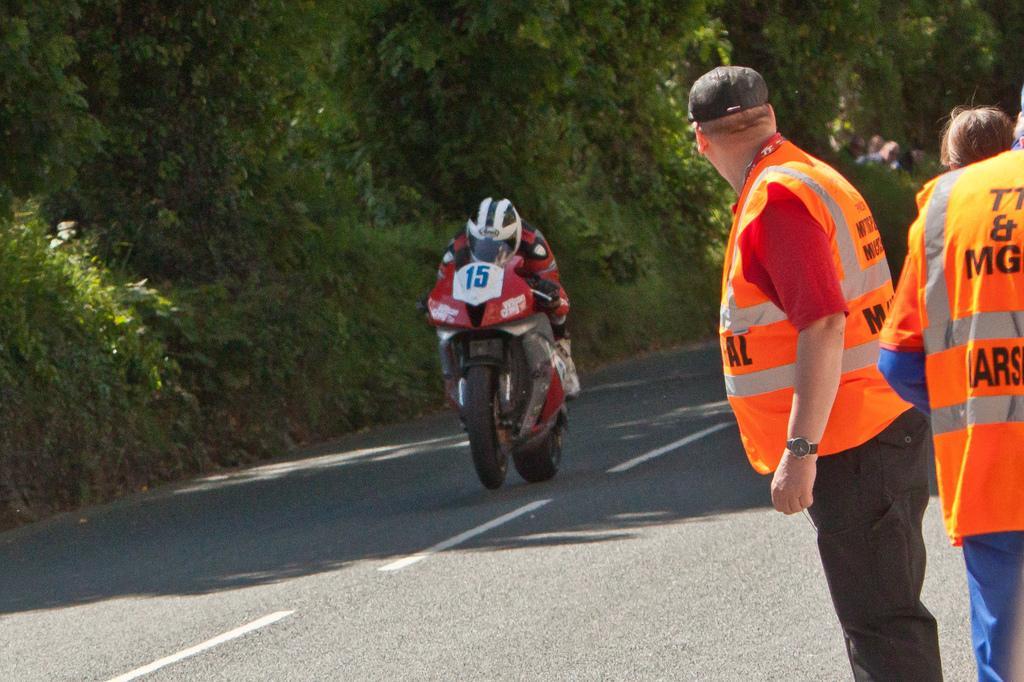Could you give a brief overview of what you see in this image? In this picture there is a person riding a bike on a road. He is wearing a red jacket and a white helmet. Towards the right there are three persons , wearing a orange jackets. In the background there are group of trees. 